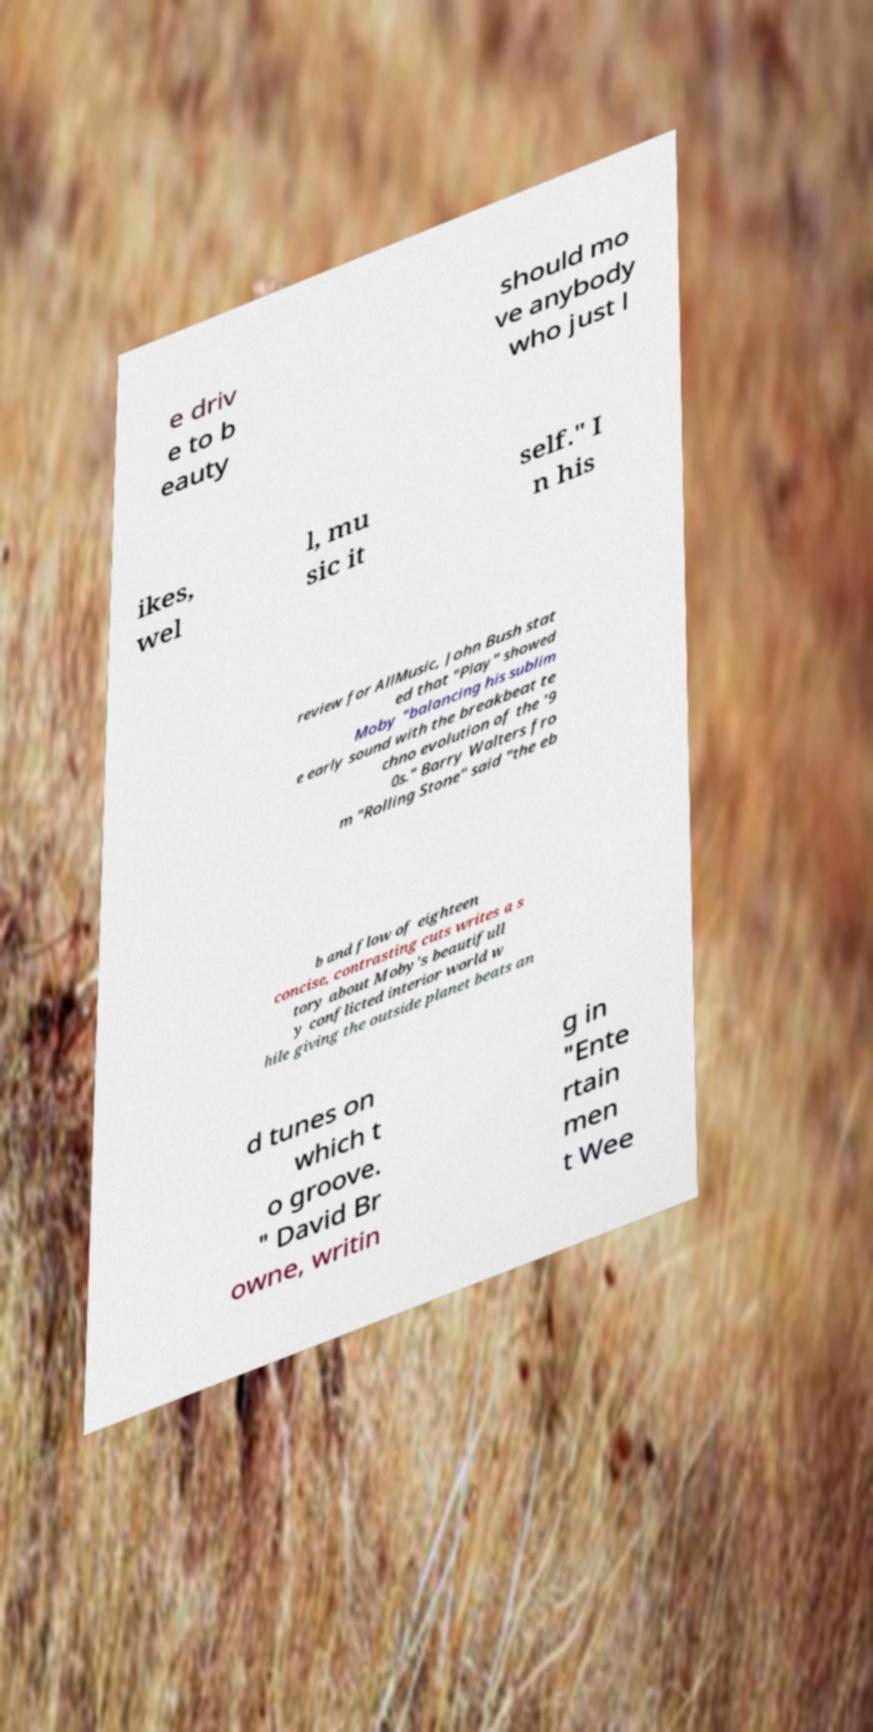Can you read and provide the text displayed in the image?This photo seems to have some interesting text. Can you extract and type it out for me? e driv e to b eauty should mo ve anybody who just l ikes, wel l, mu sic it self." I n his review for AllMusic, John Bush stat ed that "Play" showed Moby "balancing his sublim e early sound with the breakbeat te chno evolution of the '9 0s." Barry Walters fro m "Rolling Stone" said "the eb b and flow of eighteen concise, contrasting cuts writes a s tory about Moby's beautifull y conflicted interior world w hile giving the outside planet beats an d tunes on which t o groove. " David Br owne, writin g in "Ente rtain men t Wee 